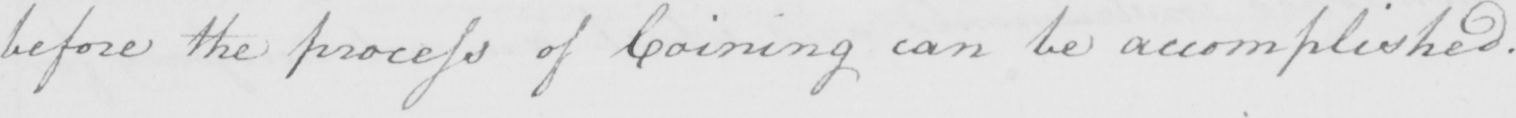Please provide the text content of this handwritten line. before the process of Coining can be accomplished . 